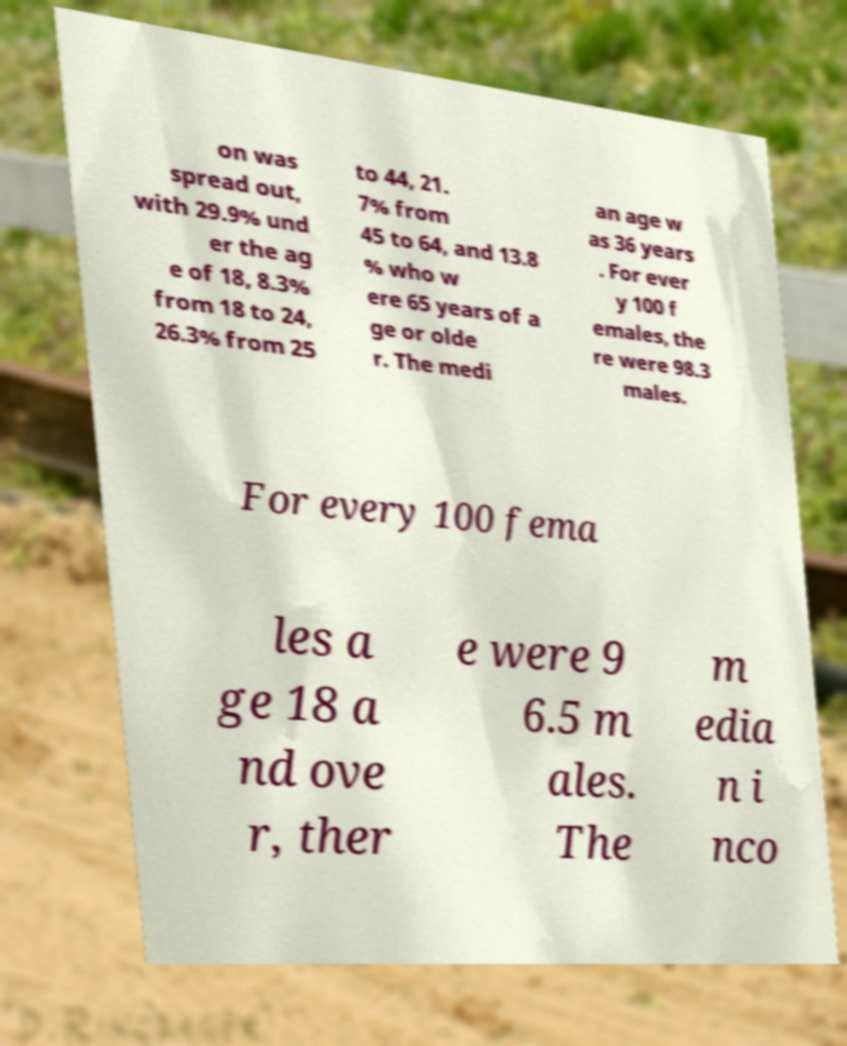Please read and relay the text visible in this image. What does it say? on was spread out, with 29.9% und er the ag e of 18, 8.3% from 18 to 24, 26.3% from 25 to 44, 21. 7% from 45 to 64, and 13.8 % who w ere 65 years of a ge or olde r. The medi an age w as 36 years . For ever y 100 f emales, the re were 98.3 males. For every 100 fema les a ge 18 a nd ove r, ther e were 9 6.5 m ales. The m edia n i nco 